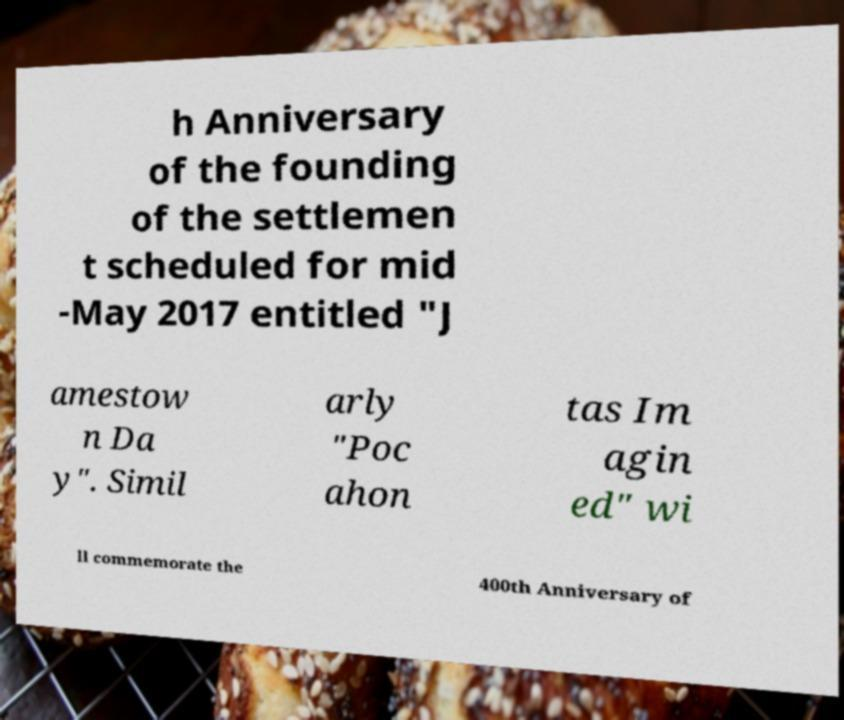Please read and relay the text visible in this image. What does it say? h Anniversary of the founding of the settlemen t scheduled for mid -May 2017 entitled "J amestow n Da y". Simil arly "Poc ahon tas Im agin ed" wi ll commemorate the 400th Anniversary of 